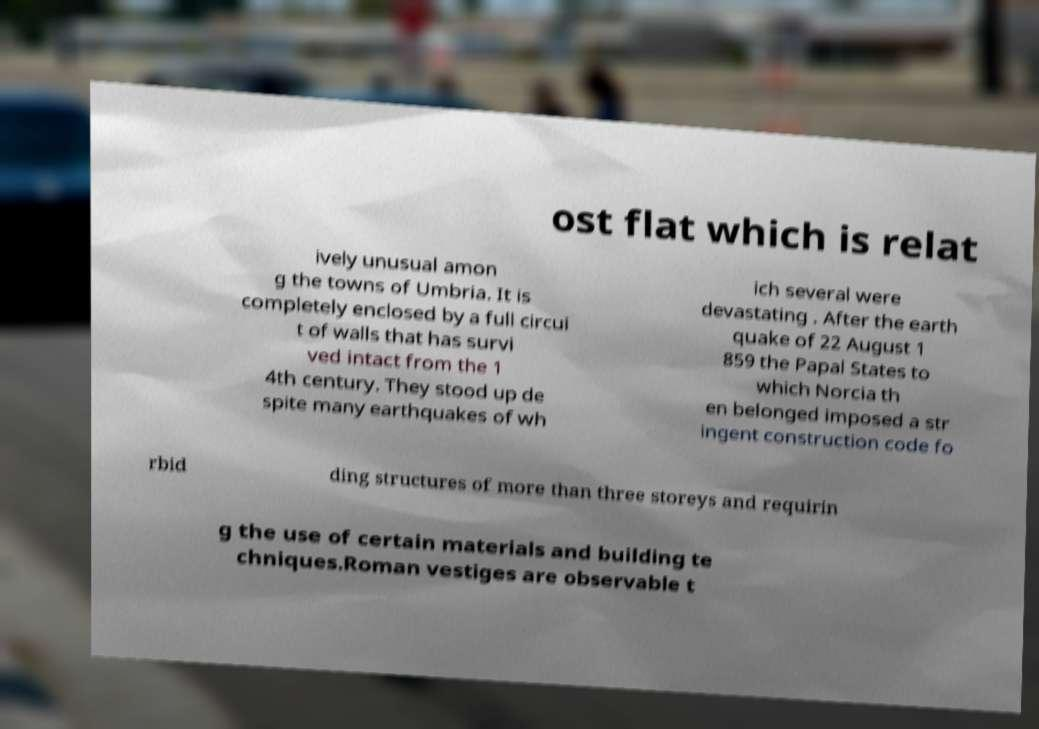Please read and relay the text visible in this image. What does it say? ost flat which is relat ively unusual amon g the towns of Umbria. It is completely enclosed by a full circui t of walls that has survi ved intact from the 1 4th century. They stood up de spite many earthquakes of wh ich several were devastating . After the earth quake of 22 August 1 859 the Papal States to which Norcia th en belonged imposed a str ingent construction code fo rbid ding structures of more than three storeys and requirin g the use of certain materials and building te chniques.Roman vestiges are observable t 